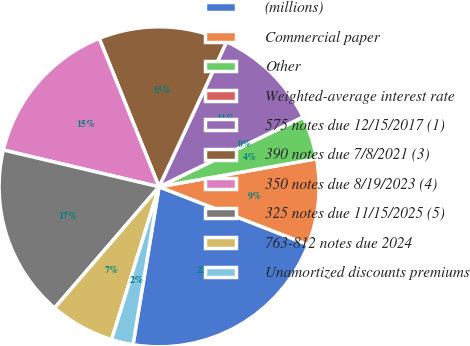Convert chart. <chart><loc_0><loc_0><loc_500><loc_500><pie_chart><fcel>(millions)<fcel>Commercial paper<fcel>Other<fcel>Weighted-average interest rate<fcel>575 notes due 12/15/2017 (1)<fcel>390 notes due 7/8/2021 (3)<fcel>350 notes due 8/19/2023 (4)<fcel>325 notes due 11/15/2025 (5)<fcel>763-812 notes due 2024<fcel>Unamortized discounts premiums<nl><fcel>21.71%<fcel>8.7%<fcel>4.36%<fcel>0.02%<fcel>10.87%<fcel>13.04%<fcel>15.2%<fcel>17.37%<fcel>6.53%<fcel>2.19%<nl></chart> 